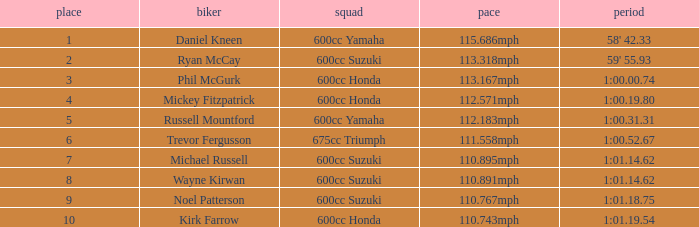What time has phil mcgurk as the rider? 1:00.00.74. 